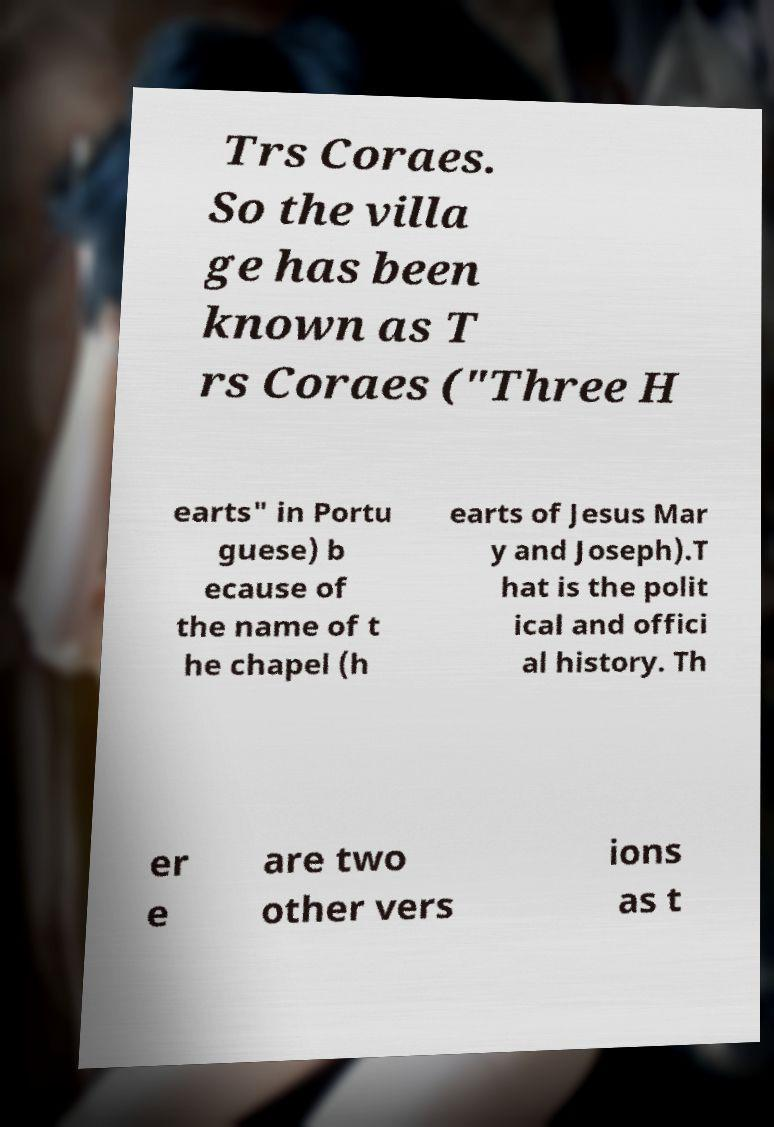Can you read and provide the text displayed in the image?This photo seems to have some interesting text. Can you extract and type it out for me? Trs Coraes. So the villa ge has been known as T rs Coraes ("Three H earts" in Portu guese) b ecause of the name of t he chapel (h earts of Jesus Mar y and Joseph).T hat is the polit ical and offici al history. Th er e are two other vers ions as t 